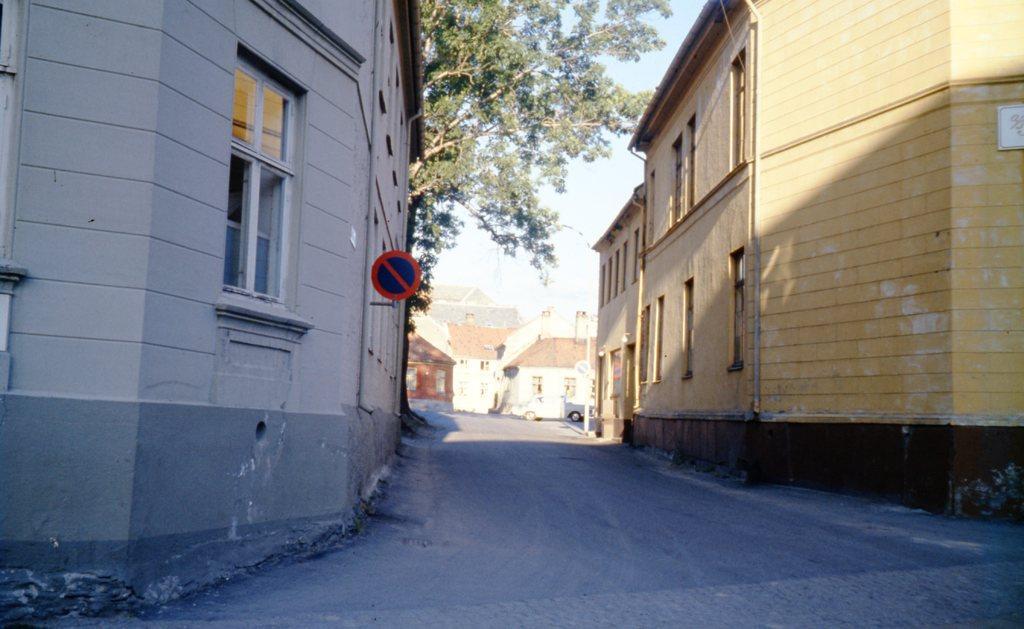Describe this image in one or two sentences. In this picture we can see buildings where, there is a sign board here, we can see a tree in the middle, there is a car here, we can see the sky at the top of the picture. 